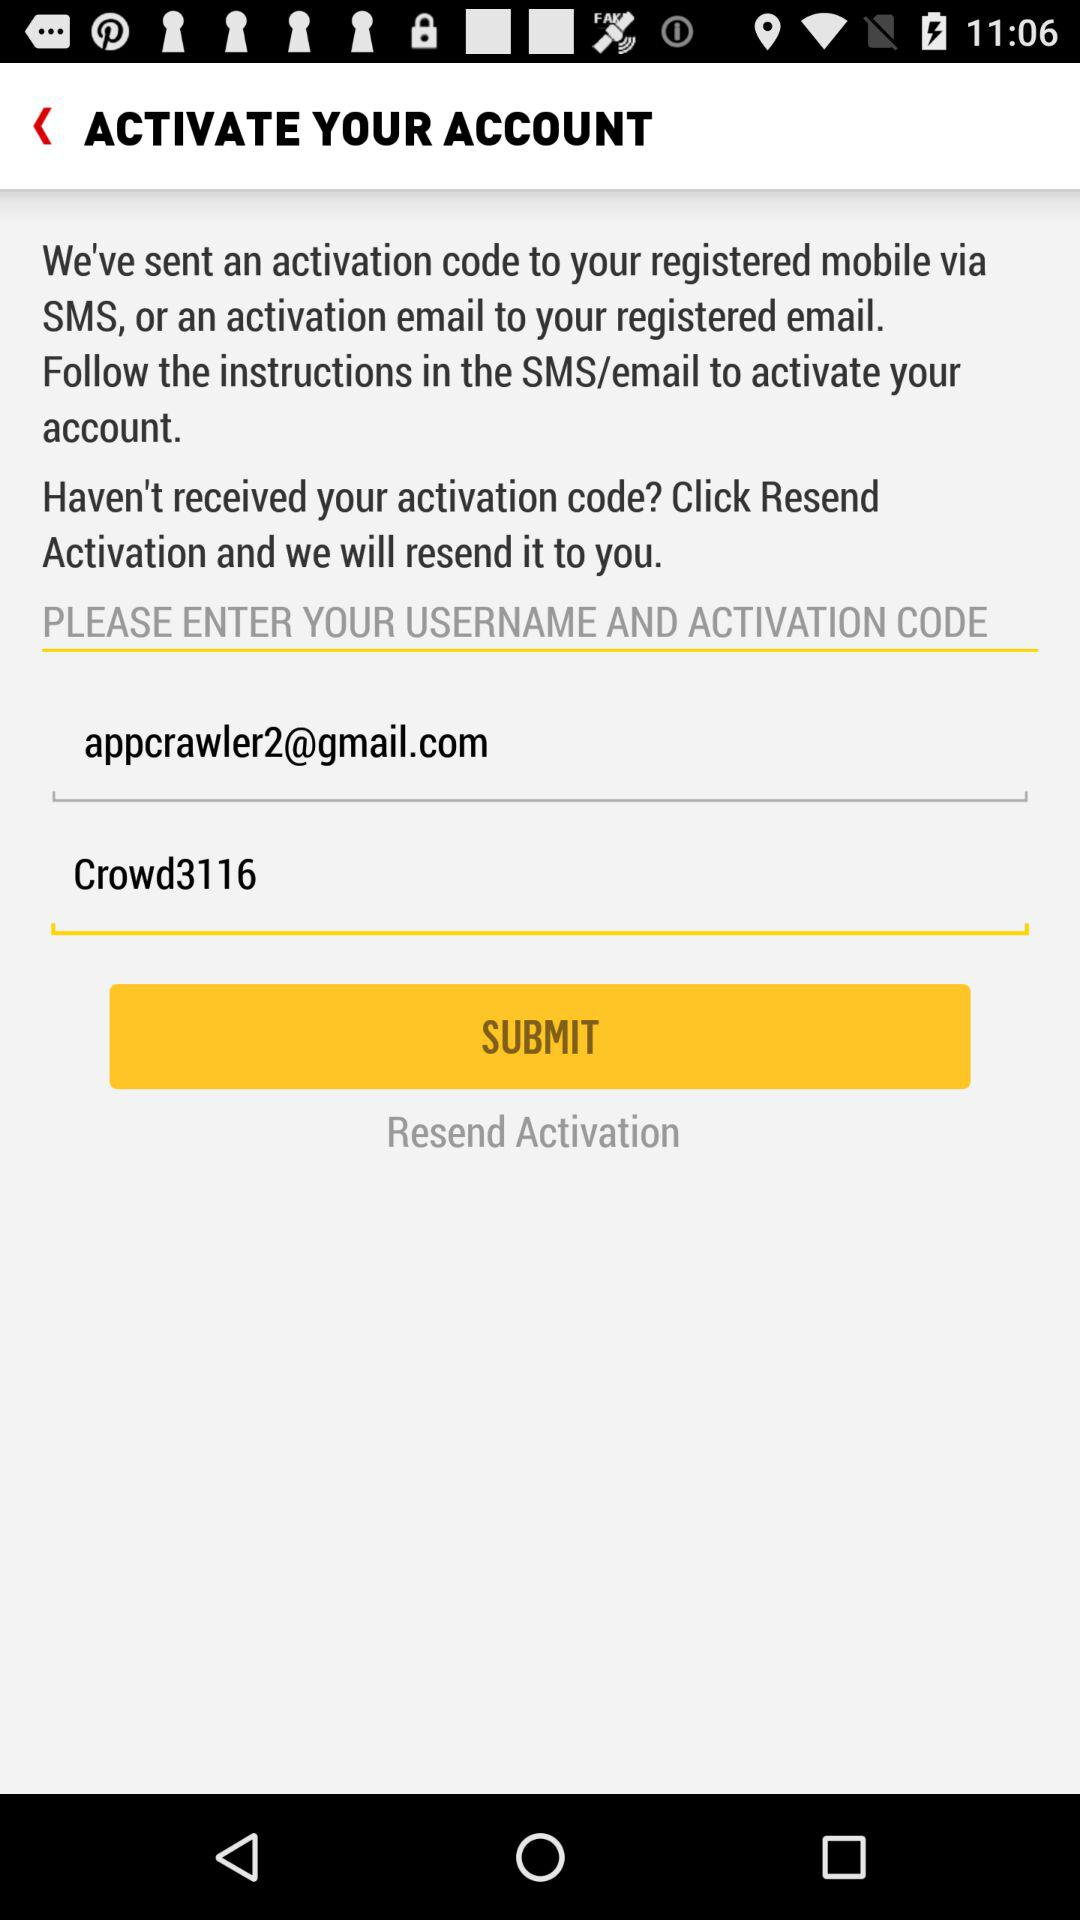What's the Gmail address? The Gmail address is appcrawler2@gmail.com. 